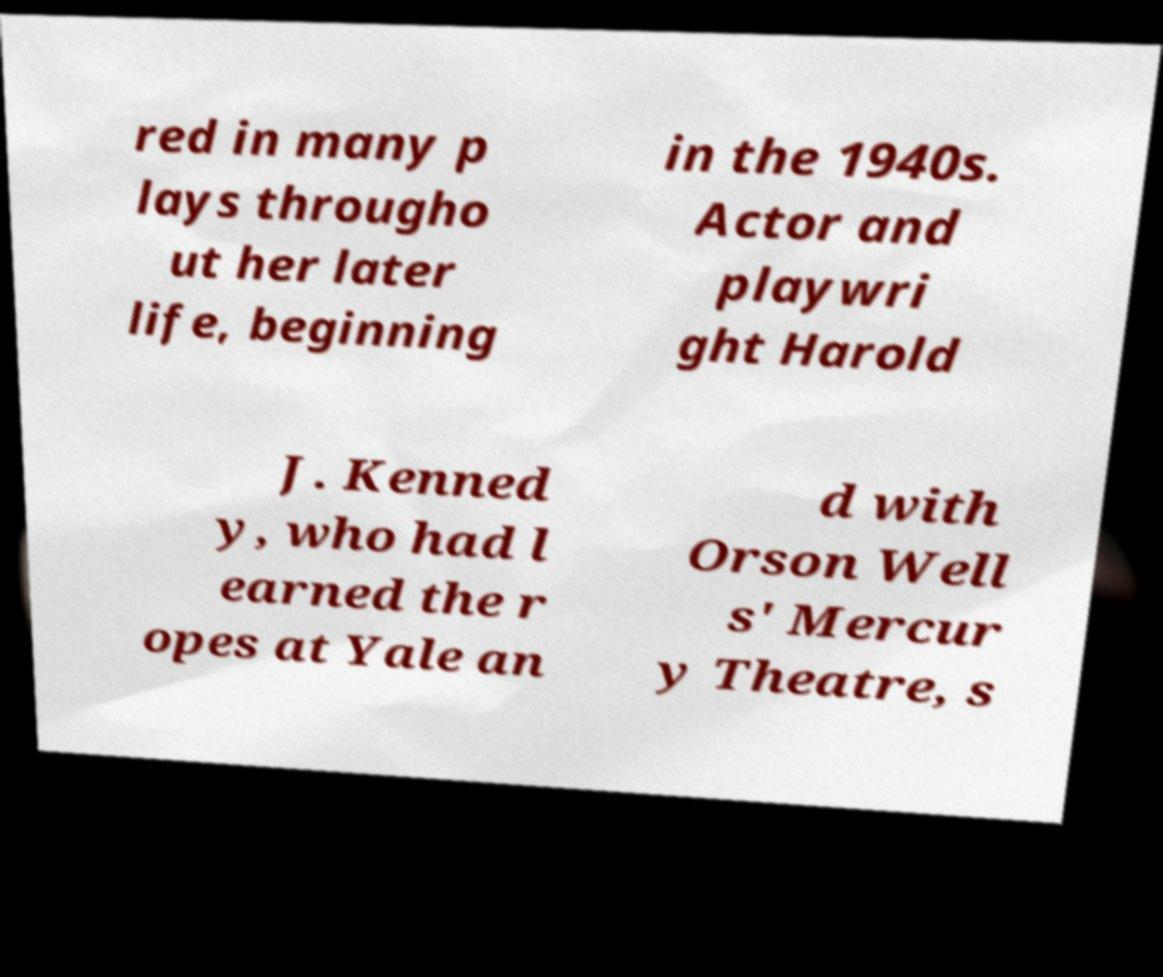For documentation purposes, I need the text within this image transcribed. Could you provide that? red in many p lays througho ut her later life, beginning in the 1940s. Actor and playwri ght Harold J. Kenned y, who had l earned the r opes at Yale an d with Orson Well s' Mercur y Theatre, s 